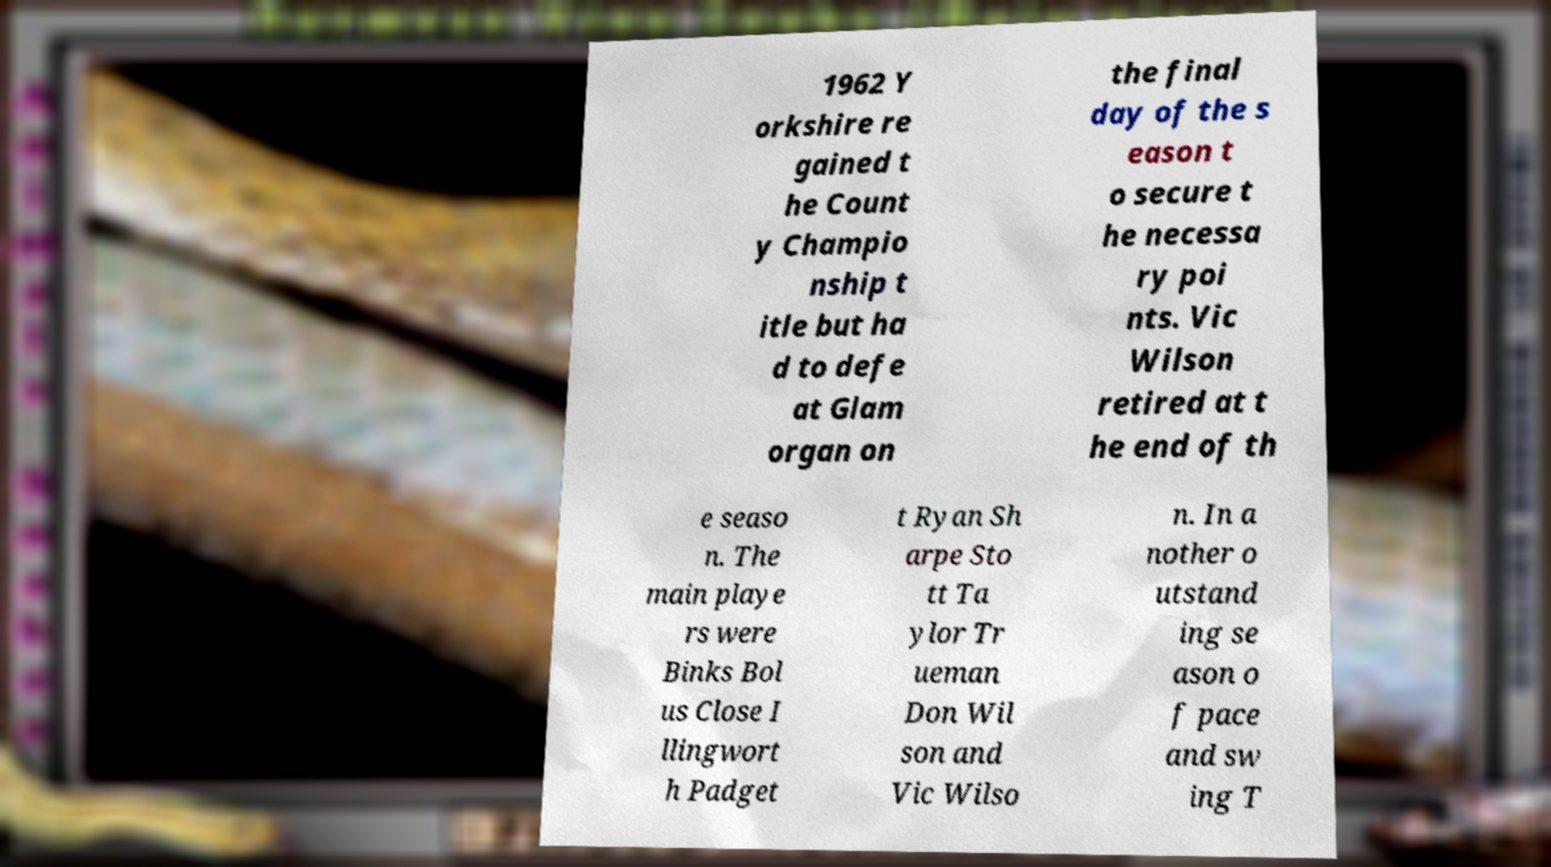I need the written content from this picture converted into text. Can you do that? 1962 Y orkshire re gained t he Count y Champio nship t itle but ha d to defe at Glam organ on the final day of the s eason t o secure t he necessa ry poi nts. Vic Wilson retired at t he end of th e seaso n. The main playe rs were Binks Bol us Close I llingwort h Padget t Ryan Sh arpe Sto tt Ta ylor Tr ueman Don Wil son and Vic Wilso n. In a nother o utstand ing se ason o f pace and sw ing T 